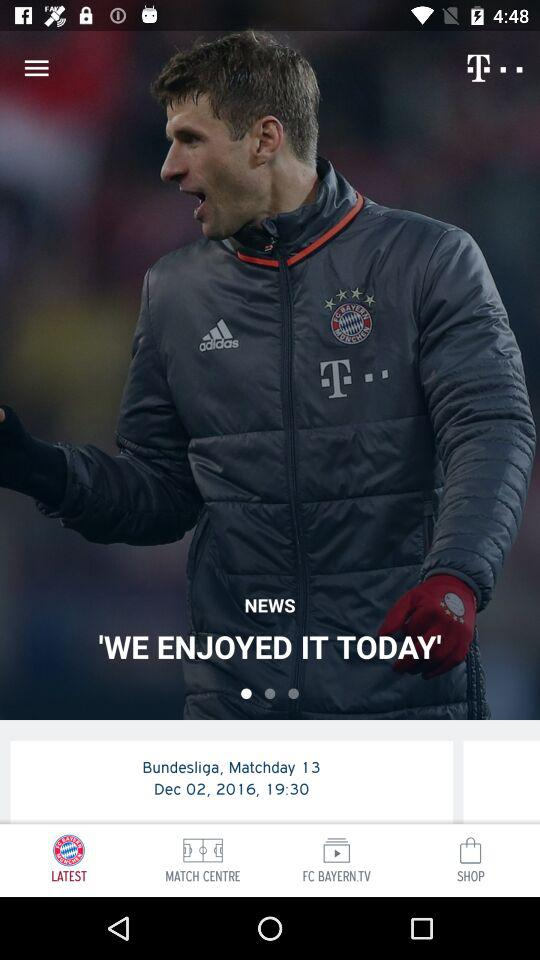What day of the match are we on? You are on the 13th day of the match. 